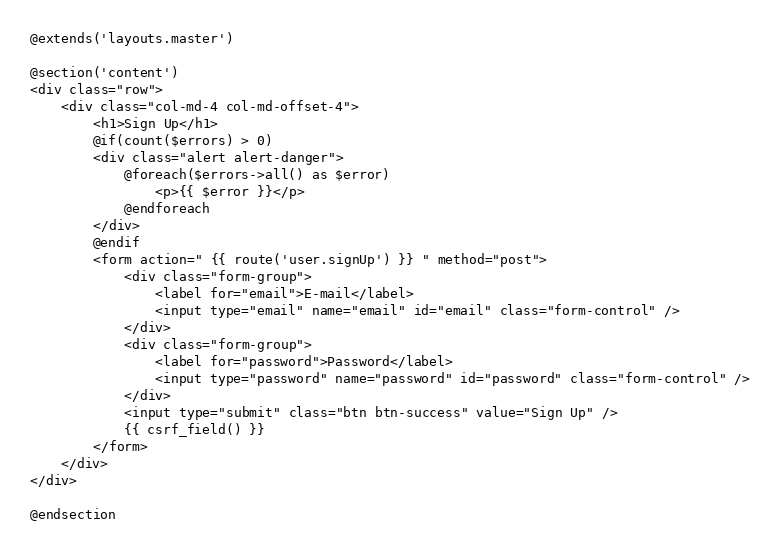<code> <loc_0><loc_0><loc_500><loc_500><_PHP_>@extends('layouts.master')

@section('content')
<div class="row">
	<div class="col-md-4 col-md-offset-4">
		<h1>Sign Up</h1>
		@if(count($errors) > 0)
		<div class="alert alert-danger">
			@foreach($errors->all() as $error)
				<p>{{ $error }}</p>
			@endforeach
		</div>
		@endif
		<form action=" {{ route('user.signUp') }} " method="post">
			<div class="form-group">
				<label for="email">E-mail</label>
				<input type="email" name="email" id="email" class="form-control" />
			</div>
			<div class="form-group">
				<label for="password">Password</label>
				<input type="password" name="password" id="password" class="form-control" />
			</div>
			<input type="submit" class="btn btn-success" value="Sign Up" />
			{{ csrf_field() }}
		</form>
	</div>
</div>

@endsection</code> 